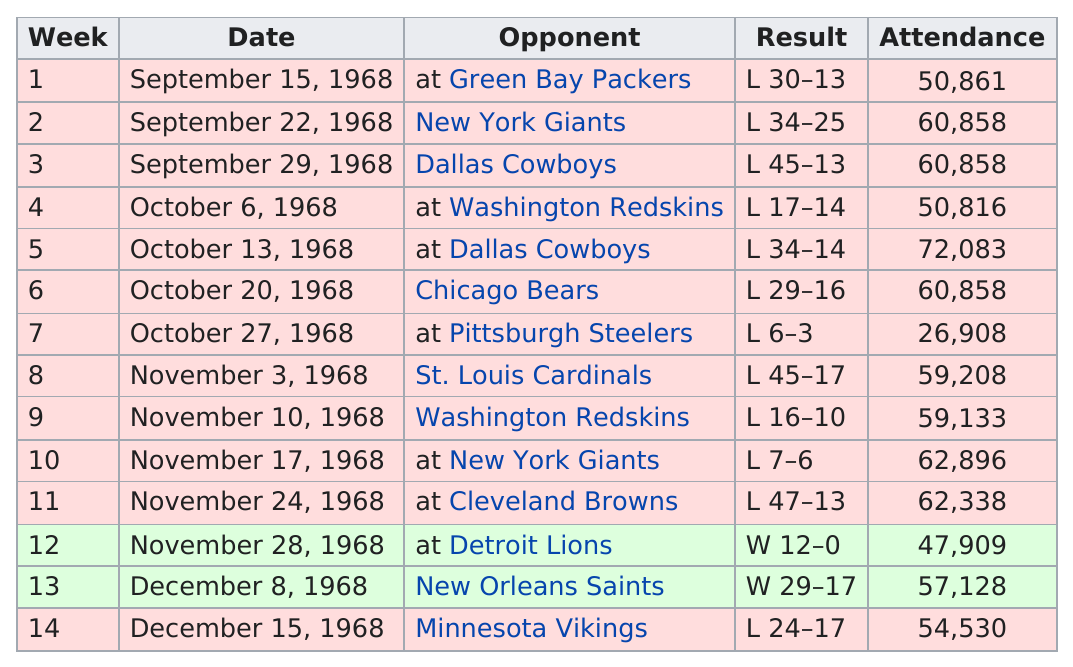Draw attention to some important aspects in this diagram. The attendance at 12 games during the season exceeded 50,000 people. The Eagles lost a total of six games in which they were defeated by more than 10 points. After December 1, 1968, the Philadelphia Eagles won a total of one game. The Eagles scored 29 points in week 13. The date of October 13, 1968, had the highest attendance. 